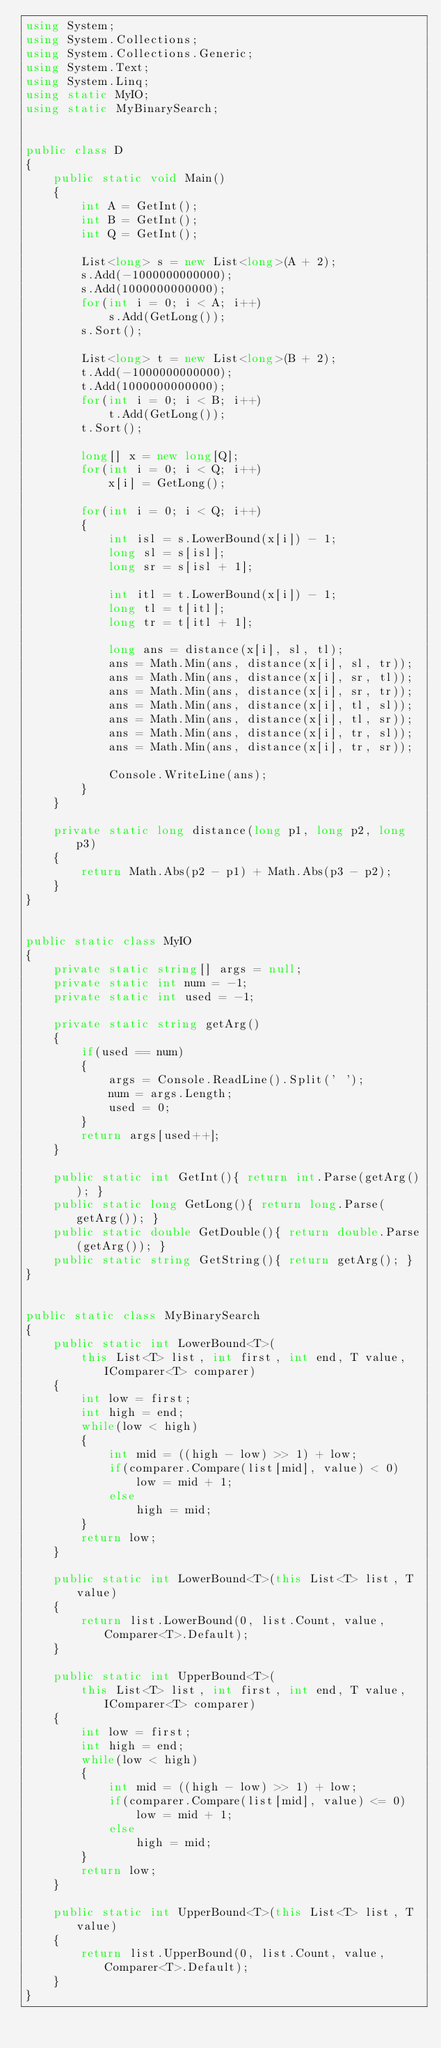Convert code to text. <code><loc_0><loc_0><loc_500><loc_500><_C#_>using System;
using System.Collections;
using System.Collections.Generic;
using System.Text;
using System.Linq;
using static MyIO;
using static MyBinarySearch;


public class D
{
	public static void Main()
	{
		int A = GetInt();
		int B = GetInt();
		int Q = GetInt();

		List<long> s = new List<long>(A + 2);
		s.Add(-1000000000000);
		s.Add(1000000000000);
		for(int i = 0; i < A; i++)
			s.Add(GetLong());
		s.Sort();

		List<long> t = new List<long>(B + 2);
		t.Add(-1000000000000);
		t.Add(1000000000000);
		for(int i = 0; i < B; i++)
			t.Add(GetLong());
		t.Sort();

		long[] x = new long[Q];
		for(int i = 0; i < Q; i++)
			x[i] = GetLong();

		for(int i = 0; i < Q; i++)
		{
			int isl = s.LowerBound(x[i]) - 1;
			long sl = s[isl];
			long sr = s[isl + 1];

			int itl = t.LowerBound(x[i]) - 1;
			long tl = t[itl];
			long tr = t[itl + 1];

			long ans = distance(x[i], sl, tl);
			ans = Math.Min(ans, distance(x[i], sl, tr));
			ans = Math.Min(ans, distance(x[i], sr, tl));
			ans = Math.Min(ans, distance(x[i], sr, tr));
			ans = Math.Min(ans, distance(x[i], tl, sl));
			ans = Math.Min(ans, distance(x[i], tl, sr));
			ans = Math.Min(ans, distance(x[i], tr, sl));
			ans = Math.Min(ans, distance(x[i], tr, sr));

			Console.WriteLine(ans);
		}
	}

	private static long distance(long p1, long p2, long p3)
	{
		return Math.Abs(p2 - p1) + Math.Abs(p3 - p2);
	}
}


public static class MyIO
{
	private static string[] args = null;
	private static int num = -1;
	private static int used = -1;

	private static string getArg()
	{
		if(used == num)
		{
			args = Console.ReadLine().Split(' ');
			num = args.Length;
			used = 0;
		}
		return args[used++];
	}

	public static int GetInt(){ return int.Parse(getArg()); }
	public static long GetLong(){ return long.Parse(getArg()); }
	public static double GetDouble(){ return double.Parse(getArg()); }
	public static string GetString(){ return getArg(); }
}


public static class MyBinarySearch
{
	public static int LowerBound<T>(
		this List<T> list, int first, int end, T value, IComparer<T> comparer)
	{
		int low = first;
		int high = end;
		while(low < high)
		{
			int mid = ((high - low) >> 1) + low;
			if(comparer.Compare(list[mid], value) < 0)
				low = mid + 1;
			else
				high = mid;
		}
		return low;
	}

	public static int LowerBound<T>(this List<T> list, T value)
	{
		return list.LowerBound(0, list.Count, value, Comparer<T>.Default);
	}

	public static int UpperBound<T>(
		this List<T> list, int first, int end, T value, IComparer<T> comparer)
	{
		int low = first;
		int high = end;
		while(low < high)
		{
			int mid = ((high - low) >> 1) + low;
			if(comparer.Compare(list[mid], value) <= 0)
				low = mid + 1;
			else
				high = mid;
		}
		return low;
	}

	public static int UpperBound<T>(this List<T> list, T value)
	{
		return list.UpperBound(0, list.Count, value, Comparer<T>.Default);
	}
}


</code> 